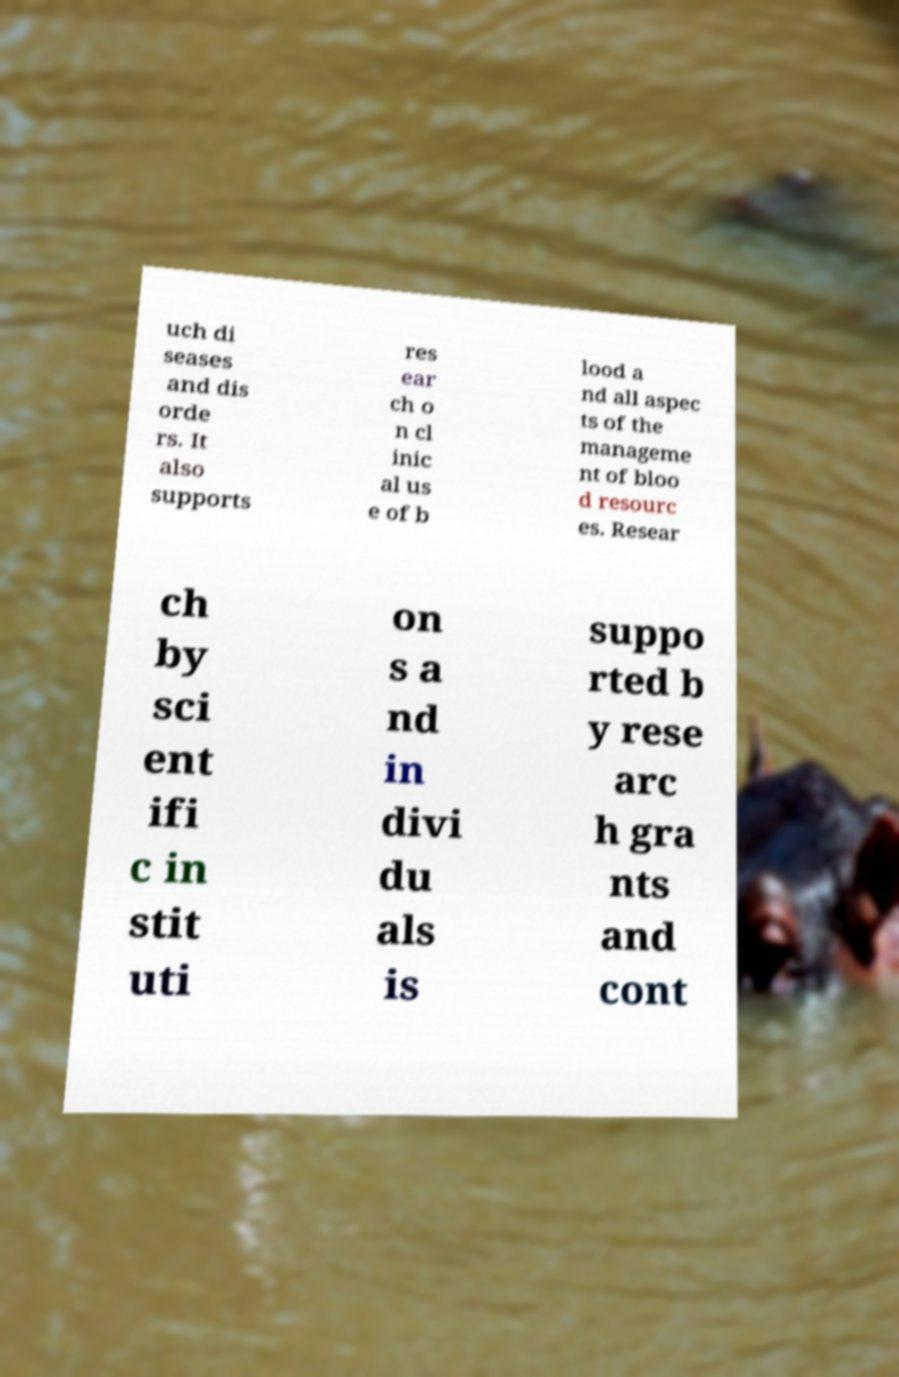For documentation purposes, I need the text within this image transcribed. Could you provide that? uch di seases and dis orde rs. It also supports res ear ch o n cl inic al us e of b lood a nd all aspec ts of the manageme nt of bloo d resourc es. Resear ch by sci ent ifi c in stit uti on s a nd in divi du als is suppo rted b y rese arc h gra nts and cont 